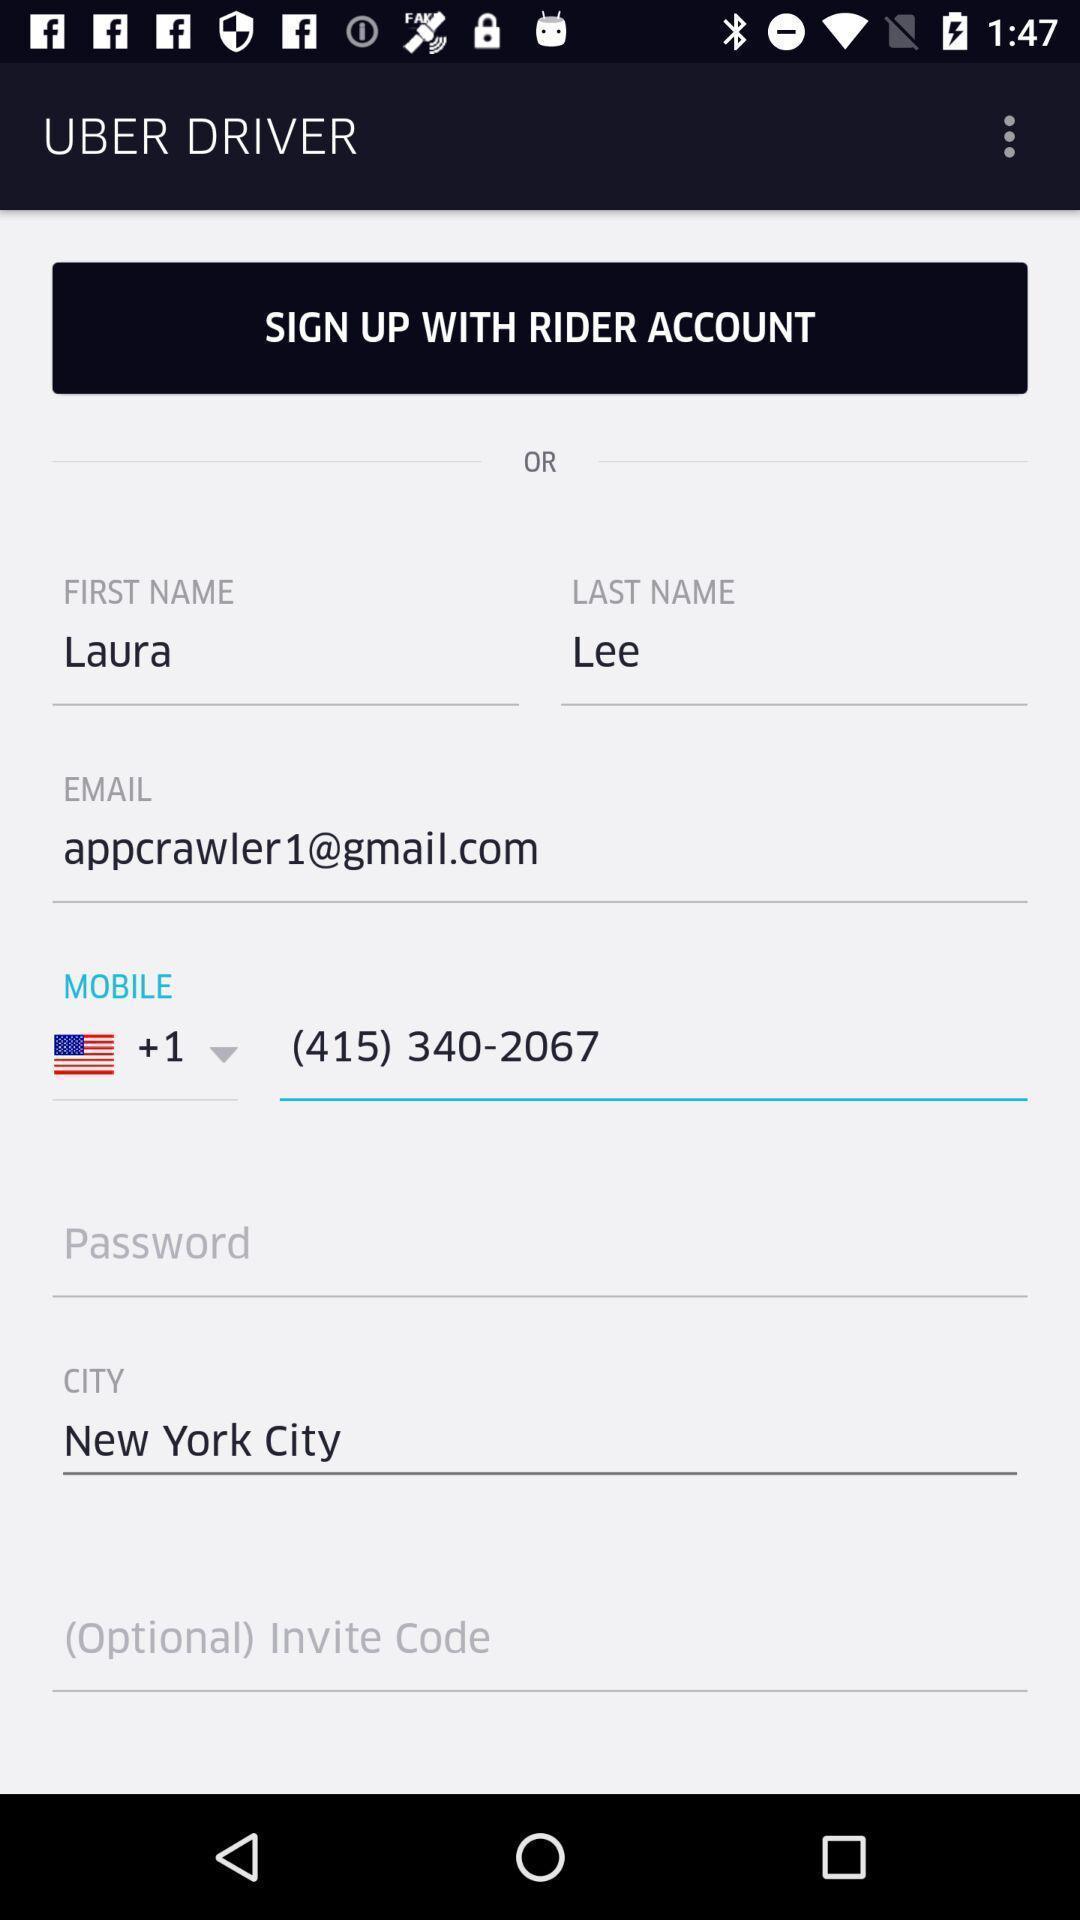What is the overall content of this screenshot? Sign up page of a travel app. 